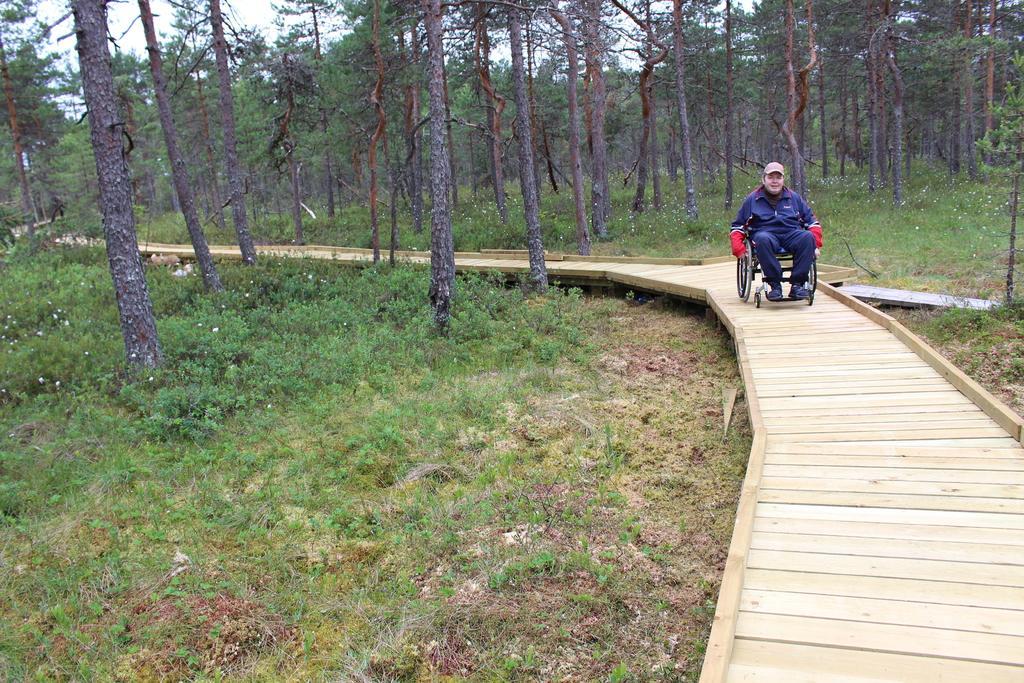Describe this image in one or two sentences. In this picture there is a man who is wearing jacket, trouser, gloves and shoe. He is sitting on the wheelchair. Here we can see wooden road. On the bottom left we can see grass and plants. In the background we can see trees. Here it's a sky. 